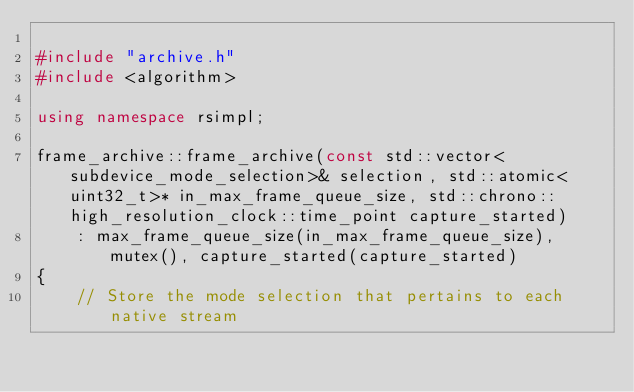<code> <loc_0><loc_0><loc_500><loc_500><_C++_>
#include "archive.h"
#include <algorithm>

using namespace rsimpl;

frame_archive::frame_archive(const std::vector<subdevice_mode_selection>& selection, std::atomic<uint32_t>* in_max_frame_queue_size, std::chrono::high_resolution_clock::time_point capture_started)
    : max_frame_queue_size(in_max_frame_queue_size), mutex(), capture_started(capture_started)
{
    // Store the mode selection that pertains to each native stream</code> 